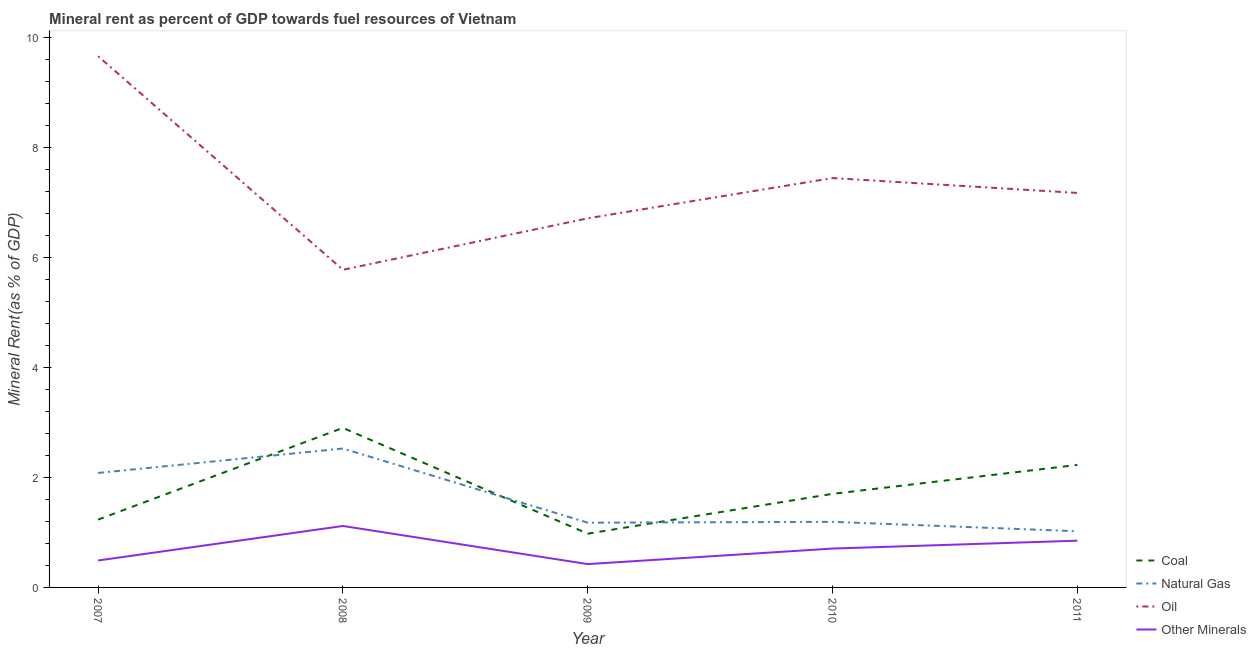How many different coloured lines are there?
Your answer should be compact. 4. Does the line corresponding to oil rent intersect with the line corresponding to  rent of other minerals?
Offer a terse response. No. Is the number of lines equal to the number of legend labels?
Offer a very short reply. Yes. What is the  rent of other minerals in 2007?
Provide a short and direct response. 0.49. Across all years, what is the maximum oil rent?
Provide a succinct answer. 9.67. Across all years, what is the minimum oil rent?
Offer a very short reply. 5.78. In which year was the coal rent maximum?
Your answer should be compact. 2008. What is the total natural gas rent in the graph?
Offer a terse response. 8. What is the difference between the oil rent in 2009 and that in 2010?
Provide a short and direct response. -0.73. What is the difference between the coal rent in 2011 and the  rent of other minerals in 2010?
Your response must be concise. 1.52. What is the average natural gas rent per year?
Your answer should be very brief. 1.6. In the year 2007, what is the difference between the oil rent and natural gas rent?
Give a very brief answer. 7.58. In how many years, is the  rent of other minerals greater than 5.2 %?
Give a very brief answer. 0. What is the ratio of the coal rent in 2008 to that in 2009?
Keep it short and to the point. 2.97. Is the natural gas rent in 2007 less than that in 2011?
Keep it short and to the point. No. What is the difference between the highest and the second highest coal rent?
Offer a very short reply. 0.67. What is the difference between the highest and the lowest natural gas rent?
Offer a very short reply. 1.51. In how many years, is the oil rent greater than the average oil rent taken over all years?
Keep it short and to the point. 2. Is the sum of the oil rent in 2007 and 2010 greater than the maximum coal rent across all years?
Ensure brevity in your answer.  Yes. Is it the case that in every year, the sum of the coal rent and natural gas rent is greater than the oil rent?
Provide a short and direct response. No. Does the  rent of other minerals monotonically increase over the years?
Make the answer very short. No. Is the  rent of other minerals strictly less than the natural gas rent over the years?
Keep it short and to the point. Yes. How many lines are there?
Make the answer very short. 4. How many years are there in the graph?
Your answer should be compact. 5. Are the values on the major ticks of Y-axis written in scientific E-notation?
Your response must be concise. No. How are the legend labels stacked?
Your response must be concise. Vertical. What is the title of the graph?
Give a very brief answer. Mineral rent as percent of GDP towards fuel resources of Vietnam. Does "Denmark" appear as one of the legend labels in the graph?
Offer a very short reply. No. What is the label or title of the X-axis?
Provide a short and direct response. Year. What is the label or title of the Y-axis?
Provide a succinct answer. Mineral Rent(as % of GDP). What is the Mineral Rent(as % of GDP) in Coal in 2007?
Provide a succinct answer. 1.23. What is the Mineral Rent(as % of GDP) of Natural Gas in 2007?
Your answer should be very brief. 2.08. What is the Mineral Rent(as % of GDP) of Oil in 2007?
Provide a short and direct response. 9.67. What is the Mineral Rent(as % of GDP) of Other Minerals in 2007?
Make the answer very short. 0.49. What is the Mineral Rent(as % of GDP) in Coal in 2008?
Your response must be concise. 2.9. What is the Mineral Rent(as % of GDP) of Natural Gas in 2008?
Keep it short and to the point. 2.53. What is the Mineral Rent(as % of GDP) of Oil in 2008?
Keep it short and to the point. 5.78. What is the Mineral Rent(as % of GDP) in Other Minerals in 2008?
Your answer should be very brief. 1.12. What is the Mineral Rent(as % of GDP) of Coal in 2009?
Make the answer very short. 0.98. What is the Mineral Rent(as % of GDP) in Natural Gas in 2009?
Your answer should be very brief. 1.18. What is the Mineral Rent(as % of GDP) in Oil in 2009?
Provide a succinct answer. 6.72. What is the Mineral Rent(as % of GDP) of Other Minerals in 2009?
Your answer should be very brief. 0.42. What is the Mineral Rent(as % of GDP) in Coal in 2010?
Your answer should be very brief. 1.7. What is the Mineral Rent(as % of GDP) of Natural Gas in 2010?
Offer a terse response. 1.19. What is the Mineral Rent(as % of GDP) in Oil in 2010?
Your answer should be very brief. 7.45. What is the Mineral Rent(as % of GDP) in Other Minerals in 2010?
Keep it short and to the point. 0.71. What is the Mineral Rent(as % of GDP) in Coal in 2011?
Your response must be concise. 2.23. What is the Mineral Rent(as % of GDP) in Natural Gas in 2011?
Your answer should be very brief. 1.02. What is the Mineral Rent(as % of GDP) of Oil in 2011?
Your answer should be very brief. 7.18. What is the Mineral Rent(as % of GDP) in Other Minerals in 2011?
Your response must be concise. 0.85. Across all years, what is the maximum Mineral Rent(as % of GDP) in Coal?
Offer a very short reply. 2.9. Across all years, what is the maximum Mineral Rent(as % of GDP) in Natural Gas?
Make the answer very short. 2.53. Across all years, what is the maximum Mineral Rent(as % of GDP) in Oil?
Give a very brief answer. 9.67. Across all years, what is the maximum Mineral Rent(as % of GDP) in Other Minerals?
Your answer should be compact. 1.12. Across all years, what is the minimum Mineral Rent(as % of GDP) of Coal?
Keep it short and to the point. 0.98. Across all years, what is the minimum Mineral Rent(as % of GDP) of Natural Gas?
Give a very brief answer. 1.02. Across all years, what is the minimum Mineral Rent(as % of GDP) in Oil?
Your answer should be compact. 5.78. Across all years, what is the minimum Mineral Rent(as % of GDP) in Other Minerals?
Make the answer very short. 0.42. What is the total Mineral Rent(as % of GDP) in Coal in the graph?
Make the answer very short. 9.05. What is the total Mineral Rent(as % of GDP) of Natural Gas in the graph?
Provide a short and direct response. 8. What is the total Mineral Rent(as % of GDP) in Oil in the graph?
Your answer should be compact. 36.79. What is the total Mineral Rent(as % of GDP) of Other Minerals in the graph?
Make the answer very short. 3.59. What is the difference between the Mineral Rent(as % of GDP) of Coal in 2007 and that in 2008?
Provide a short and direct response. -1.67. What is the difference between the Mineral Rent(as % of GDP) of Natural Gas in 2007 and that in 2008?
Offer a terse response. -0.44. What is the difference between the Mineral Rent(as % of GDP) of Oil in 2007 and that in 2008?
Keep it short and to the point. 3.89. What is the difference between the Mineral Rent(as % of GDP) in Other Minerals in 2007 and that in 2008?
Your response must be concise. -0.63. What is the difference between the Mineral Rent(as % of GDP) in Coal in 2007 and that in 2009?
Make the answer very short. 0.26. What is the difference between the Mineral Rent(as % of GDP) of Natural Gas in 2007 and that in 2009?
Provide a succinct answer. 0.91. What is the difference between the Mineral Rent(as % of GDP) in Oil in 2007 and that in 2009?
Your answer should be very brief. 2.95. What is the difference between the Mineral Rent(as % of GDP) of Other Minerals in 2007 and that in 2009?
Ensure brevity in your answer.  0.07. What is the difference between the Mineral Rent(as % of GDP) in Coal in 2007 and that in 2010?
Your answer should be compact. -0.47. What is the difference between the Mineral Rent(as % of GDP) of Natural Gas in 2007 and that in 2010?
Offer a terse response. 0.89. What is the difference between the Mineral Rent(as % of GDP) of Oil in 2007 and that in 2010?
Offer a terse response. 2.22. What is the difference between the Mineral Rent(as % of GDP) of Other Minerals in 2007 and that in 2010?
Your answer should be very brief. -0.22. What is the difference between the Mineral Rent(as % of GDP) in Coal in 2007 and that in 2011?
Your answer should be very brief. -0.99. What is the difference between the Mineral Rent(as % of GDP) of Natural Gas in 2007 and that in 2011?
Give a very brief answer. 1.06. What is the difference between the Mineral Rent(as % of GDP) of Oil in 2007 and that in 2011?
Provide a succinct answer. 2.49. What is the difference between the Mineral Rent(as % of GDP) of Other Minerals in 2007 and that in 2011?
Give a very brief answer. -0.36. What is the difference between the Mineral Rent(as % of GDP) in Coal in 2008 and that in 2009?
Ensure brevity in your answer.  1.92. What is the difference between the Mineral Rent(as % of GDP) of Natural Gas in 2008 and that in 2009?
Your answer should be very brief. 1.35. What is the difference between the Mineral Rent(as % of GDP) in Oil in 2008 and that in 2009?
Offer a terse response. -0.94. What is the difference between the Mineral Rent(as % of GDP) in Other Minerals in 2008 and that in 2009?
Make the answer very short. 0.69. What is the difference between the Mineral Rent(as % of GDP) of Coal in 2008 and that in 2010?
Offer a terse response. 1.2. What is the difference between the Mineral Rent(as % of GDP) of Natural Gas in 2008 and that in 2010?
Ensure brevity in your answer.  1.33. What is the difference between the Mineral Rent(as % of GDP) of Oil in 2008 and that in 2010?
Ensure brevity in your answer.  -1.67. What is the difference between the Mineral Rent(as % of GDP) of Other Minerals in 2008 and that in 2010?
Keep it short and to the point. 0.41. What is the difference between the Mineral Rent(as % of GDP) in Coal in 2008 and that in 2011?
Offer a very short reply. 0.67. What is the difference between the Mineral Rent(as % of GDP) of Natural Gas in 2008 and that in 2011?
Ensure brevity in your answer.  1.51. What is the difference between the Mineral Rent(as % of GDP) of Oil in 2008 and that in 2011?
Keep it short and to the point. -1.4. What is the difference between the Mineral Rent(as % of GDP) in Other Minerals in 2008 and that in 2011?
Provide a succinct answer. 0.27. What is the difference between the Mineral Rent(as % of GDP) in Coal in 2009 and that in 2010?
Ensure brevity in your answer.  -0.72. What is the difference between the Mineral Rent(as % of GDP) in Natural Gas in 2009 and that in 2010?
Your answer should be very brief. -0.02. What is the difference between the Mineral Rent(as % of GDP) in Oil in 2009 and that in 2010?
Provide a succinct answer. -0.73. What is the difference between the Mineral Rent(as % of GDP) in Other Minerals in 2009 and that in 2010?
Offer a very short reply. -0.28. What is the difference between the Mineral Rent(as % of GDP) of Coal in 2009 and that in 2011?
Ensure brevity in your answer.  -1.25. What is the difference between the Mineral Rent(as % of GDP) of Natural Gas in 2009 and that in 2011?
Offer a very short reply. 0.16. What is the difference between the Mineral Rent(as % of GDP) in Oil in 2009 and that in 2011?
Keep it short and to the point. -0.46. What is the difference between the Mineral Rent(as % of GDP) of Other Minerals in 2009 and that in 2011?
Ensure brevity in your answer.  -0.43. What is the difference between the Mineral Rent(as % of GDP) in Coal in 2010 and that in 2011?
Your response must be concise. -0.53. What is the difference between the Mineral Rent(as % of GDP) of Natural Gas in 2010 and that in 2011?
Provide a short and direct response. 0.17. What is the difference between the Mineral Rent(as % of GDP) of Oil in 2010 and that in 2011?
Offer a very short reply. 0.27. What is the difference between the Mineral Rent(as % of GDP) of Other Minerals in 2010 and that in 2011?
Provide a succinct answer. -0.14. What is the difference between the Mineral Rent(as % of GDP) of Coal in 2007 and the Mineral Rent(as % of GDP) of Natural Gas in 2008?
Your response must be concise. -1.29. What is the difference between the Mineral Rent(as % of GDP) of Coal in 2007 and the Mineral Rent(as % of GDP) of Oil in 2008?
Your answer should be compact. -4.55. What is the difference between the Mineral Rent(as % of GDP) in Coal in 2007 and the Mineral Rent(as % of GDP) in Other Minerals in 2008?
Give a very brief answer. 0.12. What is the difference between the Mineral Rent(as % of GDP) in Natural Gas in 2007 and the Mineral Rent(as % of GDP) in Oil in 2008?
Your response must be concise. -3.7. What is the difference between the Mineral Rent(as % of GDP) in Natural Gas in 2007 and the Mineral Rent(as % of GDP) in Other Minerals in 2008?
Keep it short and to the point. 0.96. What is the difference between the Mineral Rent(as % of GDP) in Oil in 2007 and the Mineral Rent(as % of GDP) in Other Minerals in 2008?
Your response must be concise. 8.55. What is the difference between the Mineral Rent(as % of GDP) in Coal in 2007 and the Mineral Rent(as % of GDP) in Natural Gas in 2009?
Ensure brevity in your answer.  0.06. What is the difference between the Mineral Rent(as % of GDP) of Coal in 2007 and the Mineral Rent(as % of GDP) of Oil in 2009?
Keep it short and to the point. -5.48. What is the difference between the Mineral Rent(as % of GDP) of Coal in 2007 and the Mineral Rent(as % of GDP) of Other Minerals in 2009?
Offer a very short reply. 0.81. What is the difference between the Mineral Rent(as % of GDP) of Natural Gas in 2007 and the Mineral Rent(as % of GDP) of Oil in 2009?
Make the answer very short. -4.63. What is the difference between the Mineral Rent(as % of GDP) of Natural Gas in 2007 and the Mineral Rent(as % of GDP) of Other Minerals in 2009?
Your answer should be compact. 1.66. What is the difference between the Mineral Rent(as % of GDP) of Oil in 2007 and the Mineral Rent(as % of GDP) of Other Minerals in 2009?
Make the answer very short. 9.24. What is the difference between the Mineral Rent(as % of GDP) of Coal in 2007 and the Mineral Rent(as % of GDP) of Natural Gas in 2010?
Offer a terse response. 0.04. What is the difference between the Mineral Rent(as % of GDP) of Coal in 2007 and the Mineral Rent(as % of GDP) of Oil in 2010?
Make the answer very short. -6.21. What is the difference between the Mineral Rent(as % of GDP) in Coal in 2007 and the Mineral Rent(as % of GDP) in Other Minerals in 2010?
Keep it short and to the point. 0.53. What is the difference between the Mineral Rent(as % of GDP) of Natural Gas in 2007 and the Mineral Rent(as % of GDP) of Oil in 2010?
Ensure brevity in your answer.  -5.37. What is the difference between the Mineral Rent(as % of GDP) of Natural Gas in 2007 and the Mineral Rent(as % of GDP) of Other Minerals in 2010?
Give a very brief answer. 1.38. What is the difference between the Mineral Rent(as % of GDP) in Oil in 2007 and the Mineral Rent(as % of GDP) in Other Minerals in 2010?
Provide a short and direct response. 8.96. What is the difference between the Mineral Rent(as % of GDP) of Coal in 2007 and the Mineral Rent(as % of GDP) of Natural Gas in 2011?
Keep it short and to the point. 0.21. What is the difference between the Mineral Rent(as % of GDP) in Coal in 2007 and the Mineral Rent(as % of GDP) in Oil in 2011?
Your response must be concise. -5.94. What is the difference between the Mineral Rent(as % of GDP) in Coal in 2007 and the Mineral Rent(as % of GDP) in Other Minerals in 2011?
Ensure brevity in your answer.  0.38. What is the difference between the Mineral Rent(as % of GDP) of Natural Gas in 2007 and the Mineral Rent(as % of GDP) of Oil in 2011?
Ensure brevity in your answer.  -5.1. What is the difference between the Mineral Rent(as % of GDP) in Natural Gas in 2007 and the Mineral Rent(as % of GDP) in Other Minerals in 2011?
Give a very brief answer. 1.23. What is the difference between the Mineral Rent(as % of GDP) of Oil in 2007 and the Mineral Rent(as % of GDP) of Other Minerals in 2011?
Your response must be concise. 8.82. What is the difference between the Mineral Rent(as % of GDP) of Coal in 2008 and the Mineral Rent(as % of GDP) of Natural Gas in 2009?
Provide a short and direct response. 1.72. What is the difference between the Mineral Rent(as % of GDP) in Coal in 2008 and the Mineral Rent(as % of GDP) in Oil in 2009?
Offer a terse response. -3.81. What is the difference between the Mineral Rent(as % of GDP) in Coal in 2008 and the Mineral Rent(as % of GDP) in Other Minerals in 2009?
Your answer should be compact. 2.48. What is the difference between the Mineral Rent(as % of GDP) of Natural Gas in 2008 and the Mineral Rent(as % of GDP) of Oil in 2009?
Make the answer very short. -4.19. What is the difference between the Mineral Rent(as % of GDP) of Natural Gas in 2008 and the Mineral Rent(as % of GDP) of Other Minerals in 2009?
Provide a short and direct response. 2.1. What is the difference between the Mineral Rent(as % of GDP) in Oil in 2008 and the Mineral Rent(as % of GDP) in Other Minerals in 2009?
Make the answer very short. 5.36. What is the difference between the Mineral Rent(as % of GDP) of Coal in 2008 and the Mineral Rent(as % of GDP) of Natural Gas in 2010?
Your answer should be compact. 1.71. What is the difference between the Mineral Rent(as % of GDP) in Coal in 2008 and the Mineral Rent(as % of GDP) in Oil in 2010?
Ensure brevity in your answer.  -4.55. What is the difference between the Mineral Rent(as % of GDP) of Coal in 2008 and the Mineral Rent(as % of GDP) of Other Minerals in 2010?
Make the answer very short. 2.2. What is the difference between the Mineral Rent(as % of GDP) of Natural Gas in 2008 and the Mineral Rent(as % of GDP) of Oil in 2010?
Keep it short and to the point. -4.92. What is the difference between the Mineral Rent(as % of GDP) of Natural Gas in 2008 and the Mineral Rent(as % of GDP) of Other Minerals in 2010?
Keep it short and to the point. 1.82. What is the difference between the Mineral Rent(as % of GDP) in Oil in 2008 and the Mineral Rent(as % of GDP) in Other Minerals in 2010?
Keep it short and to the point. 5.07. What is the difference between the Mineral Rent(as % of GDP) of Coal in 2008 and the Mineral Rent(as % of GDP) of Natural Gas in 2011?
Provide a short and direct response. 1.88. What is the difference between the Mineral Rent(as % of GDP) of Coal in 2008 and the Mineral Rent(as % of GDP) of Oil in 2011?
Offer a very short reply. -4.28. What is the difference between the Mineral Rent(as % of GDP) in Coal in 2008 and the Mineral Rent(as % of GDP) in Other Minerals in 2011?
Your response must be concise. 2.05. What is the difference between the Mineral Rent(as % of GDP) in Natural Gas in 2008 and the Mineral Rent(as % of GDP) in Oil in 2011?
Offer a terse response. -4.65. What is the difference between the Mineral Rent(as % of GDP) in Natural Gas in 2008 and the Mineral Rent(as % of GDP) in Other Minerals in 2011?
Your answer should be compact. 1.68. What is the difference between the Mineral Rent(as % of GDP) of Oil in 2008 and the Mineral Rent(as % of GDP) of Other Minerals in 2011?
Ensure brevity in your answer.  4.93. What is the difference between the Mineral Rent(as % of GDP) in Coal in 2009 and the Mineral Rent(as % of GDP) in Natural Gas in 2010?
Ensure brevity in your answer.  -0.22. What is the difference between the Mineral Rent(as % of GDP) of Coal in 2009 and the Mineral Rent(as % of GDP) of Oil in 2010?
Provide a short and direct response. -6.47. What is the difference between the Mineral Rent(as % of GDP) of Coal in 2009 and the Mineral Rent(as % of GDP) of Other Minerals in 2010?
Your response must be concise. 0.27. What is the difference between the Mineral Rent(as % of GDP) of Natural Gas in 2009 and the Mineral Rent(as % of GDP) of Oil in 2010?
Your answer should be very brief. -6.27. What is the difference between the Mineral Rent(as % of GDP) of Natural Gas in 2009 and the Mineral Rent(as % of GDP) of Other Minerals in 2010?
Keep it short and to the point. 0.47. What is the difference between the Mineral Rent(as % of GDP) in Oil in 2009 and the Mineral Rent(as % of GDP) in Other Minerals in 2010?
Your response must be concise. 6.01. What is the difference between the Mineral Rent(as % of GDP) of Coal in 2009 and the Mineral Rent(as % of GDP) of Natural Gas in 2011?
Ensure brevity in your answer.  -0.04. What is the difference between the Mineral Rent(as % of GDP) in Coal in 2009 and the Mineral Rent(as % of GDP) in Oil in 2011?
Your answer should be very brief. -6.2. What is the difference between the Mineral Rent(as % of GDP) of Coal in 2009 and the Mineral Rent(as % of GDP) of Other Minerals in 2011?
Ensure brevity in your answer.  0.13. What is the difference between the Mineral Rent(as % of GDP) of Natural Gas in 2009 and the Mineral Rent(as % of GDP) of Oil in 2011?
Make the answer very short. -6. What is the difference between the Mineral Rent(as % of GDP) of Natural Gas in 2009 and the Mineral Rent(as % of GDP) of Other Minerals in 2011?
Offer a very short reply. 0.33. What is the difference between the Mineral Rent(as % of GDP) of Oil in 2009 and the Mineral Rent(as % of GDP) of Other Minerals in 2011?
Keep it short and to the point. 5.87. What is the difference between the Mineral Rent(as % of GDP) of Coal in 2010 and the Mineral Rent(as % of GDP) of Natural Gas in 2011?
Provide a short and direct response. 0.68. What is the difference between the Mineral Rent(as % of GDP) of Coal in 2010 and the Mineral Rent(as % of GDP) of Oil in 2011?
Offer a terse response. -5.48. What is the difference between the Mineral Rent(as % of GDP) of Coal in 2010 and the Mineral Rent(as % of GDP) of Other Minerals in 2011?
Make the answer very short. 0.85. What is the difference between the Mineral Rent(as % of GDP) in Natural Gas in 2010 and the Mineral Rent(as % of GDP) in Oil in 2011?
Your answer should be compact. -5.99. What is the difference between the Mineral Rent(as % of GDP) of Natural Gas in 2010 and the Mineral Rent(as % of GDP) of Other Minerals in 2011?
Provide a short and direct response. 0.34. What is the difference between the Mineral Rent(as % of GDP) of Oil in 2010 and the Mineral Rent(as % of GDP) of Other Minerals in 2011?
Offer a very short reply. 6.6. What is the average Mineral Rent(as % of GDP) of Coal per year?
Offer a very short reply. 1.81. What is the average Mineral Rent(as % of GDP) of Natural Gas per year?
Provide a succinct answer. 1.6. What is the average Mineral Rent(as % of GDP) in Oil per year?
Your response must be concise. 7.36. What is the average Mineral Rent(as % of GDP) of Other Minerals per year?
Offer a very short reply. 0.72. In the year 2007, what is the difference between the Mineral Rent(as % of GDP) of Coal and Mineral Rent(as % of GDP) of Natural Gas?
Keep it short and to the point. -0.85. In the year 2007, what is the difference between the Mineral Rent(as % of GDP) in Coal and Mineral Rent(as % of GDP) in Oil?
Provide a short and direct response. -8.43. In the year 2007, what is the difference between the Mineral Rent(as % of GDP) of Coal and Mineral Rent(as % of GDP) of Other Minerals?
Keep it short and to the point. 0.74. In the year 2007, what is the difference between the Mineral Rent(as % of GDP) in Natural Gas and Mineral Rent(as % of GDP) in Oil?
Offer a terse response. -7.58. In the year 2007, what is the difference between the Mineral Rent(as % of GDP) in Natural Gas and Mineral Rent(as % of GDP) in Other Minerals?
Provide a short and direct response. 1.59. In the year 2007, what is the difference between the Mineral Rent(as % of GDP) of Oil and Mineral Rent(as % of GDP) of Other Minerals?
Provide a succinct answer. 9.18. In the year 2008, what is the difference between the Mineral Rent(as % of GDP) in Coal and Mineral Rent(as % of GDP) in Natural Gas?
Your response must be concise. 0.38. In the year 2008, what is the difference between the Mineral Rent(as % of GDP) in Coal and Mineral Rent(as % of GDP) in Oil?
Keep it short and to the point. -2.88. In the year 2008, what is the difference between the Mineral Rent(as % of GDP) in Coal and Mineral Rent(as % of GDP) in Other Minerals?
Make the answer very short. 1.78. In the year 2008, what is the difference between the Mineral Rent(as % of GDP) of Natural Gas and Mineral Rent(as % of GDP) of Oil?
Your answer should be compact. -3.25. In the year 2008, what is the difference between the Mineral Rent(as % of GDP) in Natural Gas and Mineral Rent(as % of GDP) in Other Minerals?
Ensure brevity in your answer.  1.41. In the year 2008, what is the difference between the Mineral Rent(as % of GDP) of Oil and Mineral Rent(as % of GDP) of Other Minerals?
Ensure brevity in your answer.  4.66. In the year 2009, what is the difference between the Mineral Rent(as % of GDP) in Coal and Mineral Rent(as % of GDP) in Natural Gas?
Offer a very short reply. -0.2. In the year 2009, what is the difference between the Mineral Rent(as % of GDP) of Coal and Mineral Rent(as % of GDP) of Oil?
Offer a terse response. -5.74. In the year 2009, what is the difference between the Mineral Rent(as % of GDP) of Coal and Mineral Rent(as % of GDP) of Other Minerals?
Make the answer very short. 0.55. In the year 2009, what is the difference between the Mineral Rent(as % of GDP) of Natural Gas and Mineral Rent(as % of GDP) of Oil?
Offer a very short reply. -5.54. In the year 2009, what is the difference between the Mineral Rent(as % of GDP) in Natural Gas and Mineral Rent(as % of GDP) in Other Minerals?
Offer a terse response. 0.75. In the year 2009, what is the difference between the Mineral Rent(as % of GDP) of Oil and Mineral Rent(as % of GDP) of Other Minerals?
Provide a succinct answer. 6.29. In the year 2010, what is the difference between the Mineral Rent(as % of GDP) of Coal and Mineral Rent(as % of GDP) of Natural Gas?
Your answer should be compact. 0.51. In the year 2010, what is the difference between the Mineral Rent(as % of GDP) in Coal and Mineral Rent(as % of GDP) in Oil?
Your answer should be very brief. -5.75. In the year 2010, what is the difference between the Mineral Rent(as % of GDP) of Coal and Mineral Rent(as % of GDP) of Other Minerals?
Provide a succinct answer. 1. In the year 2010, what is the difference between the Mineral Rent(as % of GDP) of Natural Gas and Mineral Rent(as % of GDP) of Oil?
Provide a short and direct response. -6.26. In the year 2010, what is the difference between the Mineral Rent(as % of GDP) of Natural Gas and Mineral Rent(as % of GDP) of Other Minerals?
Your response must be concise. 0.49. In the year 2010, what is the difference between the Mineral Rent(as % of GDP) in Oil and Mineral Rent(as % of GDP) in Other Minerals?
Ensure brevity in your answer.  6.74. In the year 2011, what is the difference between the Mineral Rent(as % of GDP) in Coal and Mineral Rent(as % of GDP) in Natural Gas?
Your response must be concise. 1.21. In the year 2011, what is the difference between the Mineral Rent(as % of GDP) in Coal and Mineral Rent(as % of GDP) in Oil?
Make the answer very short. -4.95. In the year 2011, what is the difference between the Mineral Rent(as % of GDP) in Coal and Mineral Rent(as % of GDP) in Other Minerals?
Your answer should be compact. 1.38. In the year 2011, what is the difference between the Mineral Rent(as % of GDP) in Natural Gas and Mineral Rent(as % of GDP) in Oil?
Provide a short and direct response. -6.16. In the year 2011, what is the difference between the Mineral Rent(as % of GDP) in Natural Gas and Mineral Rent(as % of GDP) in Other Minerals?
Offer a terse response. 0.17. In the year 2011, what is the difference between the Mineral Rent(as % of GDP) in Oil and Mineral Rent(as % of GDP) in Other Minerals?
Your response must be concise. 6.33. What is the ratio of the Mineral Rent(as % of GDP) in Coal in 2007 to that in 2008?
Your answer should be compact. 0.43. What is the ratio of the Mineral Rent(as % of GDP) in Natural Gas in 2007 to that in 2008?
Ensure brevity in your answer.  0.82. What is the ratio of the Mineral Rent(as % of GDP) of Oil in 2007 to that in 2008?
Offer a very short reply. 1.67. What is the ratio of the Mineral Rent(as % of GDP) in Other Minerals in 2007 to that in 2008?
Offer a terse response. 0.44. What is the ratio of the Mineral Rent(as % of GDP) of Coal in 2007 to that in 2009?
Provide a short and direct response. 1.26. What is the ratio of the Mineral Rent(as % of GDP) in Natural Gas in 2007 to that in 2009?
Give a very brief answer. 1.77. What is the ratio of the Mineral Rent(as % of GDP) in Oil in 2007 to that in 2009?
Make the answer very short. 1.44. What is the ratio of the Mineral Rent(as % of GDP) in Other Minerals in 2007 to that in 2009?
Keep it short and to the point. 1.15. What is the ratio of the Mineral Rent(as % of GDP) of Coal in 2007 to that in 2010?
Provide a succinct answer. 0.72. What is the ratio of the Mineral Rent(as % of GDP) in Natural Gas in 2007 to that in 2010?
Offer a terse response. 1.75. What is the ratio of the Mineral Rent(as % of GDP) in Oil in 2007 to that in 2010?
Provide a short and direct response. 1.3. What is the ratio of the Mineral Rent(as % of GDP) of Other Minerals in 2007 to that in 2010?
Provide a succinct answer. 0.69. What is the ratio of the Mineral Rent(as % of GDP) in Coal in 2007 to that in 2011?
Offer a very short reply. 0.55. What is the ratio of the Mineral Rent(as % of GDP) of Natural Gas in 2007 to that in 2011?
Your answer should be very brief. 2.04. What is the ratio of the Mineral Rent(as % of GDP) in Oil in 2007 to that in 2011?
Ensure brevity in your answer.  1.35. What is the ratio of the Mineral Rent(as % of GDP) in Other Minerals in 2007 to that in 2011?
Give a very brief answer. 0.58. What is the ratio of the Mineral Rent(as % of GDP) of Coal in 2008 to that in 2009?
Your answer should be compact. 2.97. What is the ratio of the Mineral Rent(as % of GDP) in Natural Gas in 2008 to that in 2009?
Your answer should be very brief. 2.15. What is the ratio of the Mineral Rent(as % of GDP) in Oil in 2008 to that in 2009?
Your answer should be compact. 0.86. What is the ratio of the Mineral Rent(as % of GDP) of Other Minerals in 2008 to that in 2009?
Keep it short and to the point. 2.63. What is the ratio of the Mineral Rent(as % of GDP) of Coal in 2008 to that in 2010?
Your answer should be very brief. 1.7. What is the ratio of the Mineral Rent(as % of GDP) of Natural Gas in 2008 to that in 2010?
Provide a short and direct response. 2.12. What is the ratio of the Mineral Rent(as % of GDP) of Oil in 2008 to that in 2010?
Your answer should be very brief. 0.78. What is the ratio of the Mineral Rent(as % of GDP) of Other Minerals in 2008 to that in 2010?
Give a very brief answer. 1.58. What is the ratio of the Mineral Rent(as % of GDP) in Coal in 2008 to that in 2011?
Provide a short and direct response. 1.3. What is the ratio of the Mineral Rent(as % of GDP) in Natural Gas in 2008 to that in 2011?
Make the answer very short. 2.47. What is the ratio of the Mineral Rent(as % of GDP) of Oil in 2008 to that in 2011?
Make the answer very short. 0.81. What is the ratio of the Mineral Rent(as % of GDP) in Other Minerals in 2008 to that in 2011?
Offer a very short reply. 1.31. What is the ratio of the Mineral Rent(as % of GDP) in Coal in 2009 to that in 2010?
Give a very brief answer. 0.57. What is the ratio of the Mineral Rent(as % of GDP) in Natural Gas in 2009 to that in 2010?
Provide a short and direct response. 0.99. What is the ratio of the Mineral Rent(as % of GDP) of Oil in 2009 to that in 2010?
Keep it short and to the point. 0.9. What is the ratio of the Mineral Rent(as % of GDP) in Other Minerals in 2009 to that in 2010?
Your answer should be very brief. 0.6. What is the ratio of the Mineral Rent(as % of GDP) of Coal in 2009 to that in 2011?
Your answer should be compact. 0.44. What is the ratio of the Mineral Rent(as % of GDP) in Natural Gas in 2009 to that in 2011?
Your answer should be compact. 1.15. What is the ratio of the Mineral Rent(as % of GDP) in Oil in 2009 to that in 2011?
Ensure brevity in your answer.  0.94. What is the ratio of the Mineral Rent(as % of GDP) of Other Minerals in 2009 to that in 2011?
Your answer should be very brief. 0.5. What is the ratio of the Mineral Rent(as % of GDP) in Coal in 2010 to that in 2011?
Your response must be concise. 0.76. What is the ratio of the Mineral Rent(as % of GDP) of Natural Gas in 2010 to that in 2011?
Provide a succinct answer. 1.17. What is the ratio of the Mineral Rent(as % of GDP) of Oil in 2010 to that in 2011?
Provide a succinct answer. 1.04. What is the ratio of the Mineral Rent(as % of GDP) in Other Minerals in 2010 to that in 2011?
Provide a short and direct response. 0.83. What is the difference between the highest and the second highest Mineral Rent(as % of GDP) in Coal?
Offer a very short reply. 0.67. What is the difference between the highest and the second highest Mineral Rent(as % of GDP) in Natural Gas?
Provide a short and direct response. 0.44. What is the difference between the highest and the second highest Mineral Rent(as % of GDP) in Oil?
Give a very brief answer. 2.22. What is the difference between the highest and the second highest Mineral Rent(as % of GDP) of Other Minerals?
Offer a terse response. 0.27. What is the difference between the highest and the lowest Mineral Rent(as % of GDP) of Coal?
Keep it short and to the point. 1.92. What is the difference between the highest and the lowest Mineral Rent(as % of GDP) in Natural Gas?
Keep it short and to the point. 1.51. What is the difference between the highest and the lowest Mineral Rent(as % of GDP) of Oil?
Your response must be concise. 3.89. What is the difference between the highest and the lowest Mineral Rent(as % of GDP) in Other Minerals?
Make the answer very short. 0.69. 